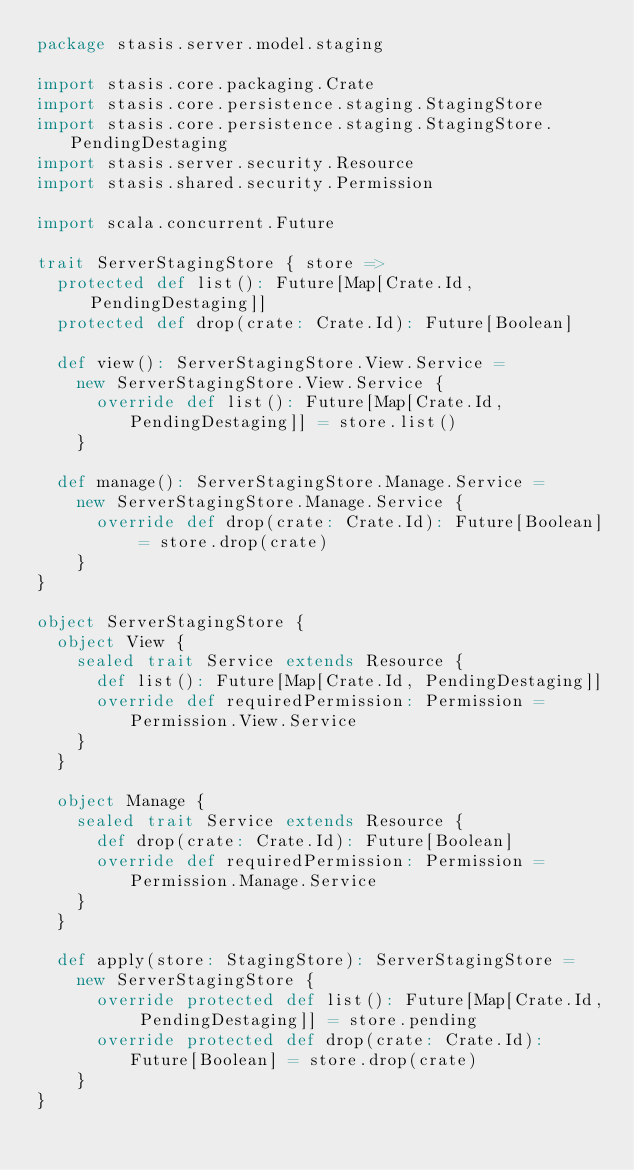<code> <loc_0><loc_0><loc_500><loc_500><_Scala_>package stasis.server.model.staging

import stasis.core.packaging.Crate
import stasis.core.persistence.staging.StagingStore
import stasis.core.persistence.staging.StagingStore.PendingDestaging
import stasis.server.security.Resource
import stasis.shared.security.Permission

import scala.concurrent.Future

trait ServerStagingStore { store =>
  protected def list(): Future[Map[Crate.Id, PendingDestaging]]
  protected def drop(crate: Crate.Id): Future[Boolean]

  def view(): ServerStagingStore.View.Service =
    new ServerStagingStore.View.Service {
      override def list(): Future[Map[Crate.Id, PendingDestaging]] = store.list()
    }

  def manage(): ServerStagingStore.Manage.Service =
    new ServerStagingStore.Manage.Service {
      override def drop(crate: Crate.Id): Future[Boolean] = store.drop(crate)
    }
}

object ServerStagingStore {
  object View {
    sealed trait Service extends Resource {
      def list(): Future[Map[Crate.Id, PendingDestaging]]
      override def requiredPermission: Permission = Permission.View.Service
    }
  }

  object Manage {
    sealed trait Service extends Resource {
      def drop(crate: Crate.Id): Future[Boolean]
      override def requiredPermission: Permission = Permission.Manage.Service
    }
  }

  def apply(store: StagingStore): ServerStagingStore =
    new ServerStagingStore {
      override protected def list(): Future[Map[Crate.Id, PendingDestaging]] = store.pending
      override protected def drop(crate: Crate.Id): Future[Boolean] = store.drop(crate)
    }
}
</code> 